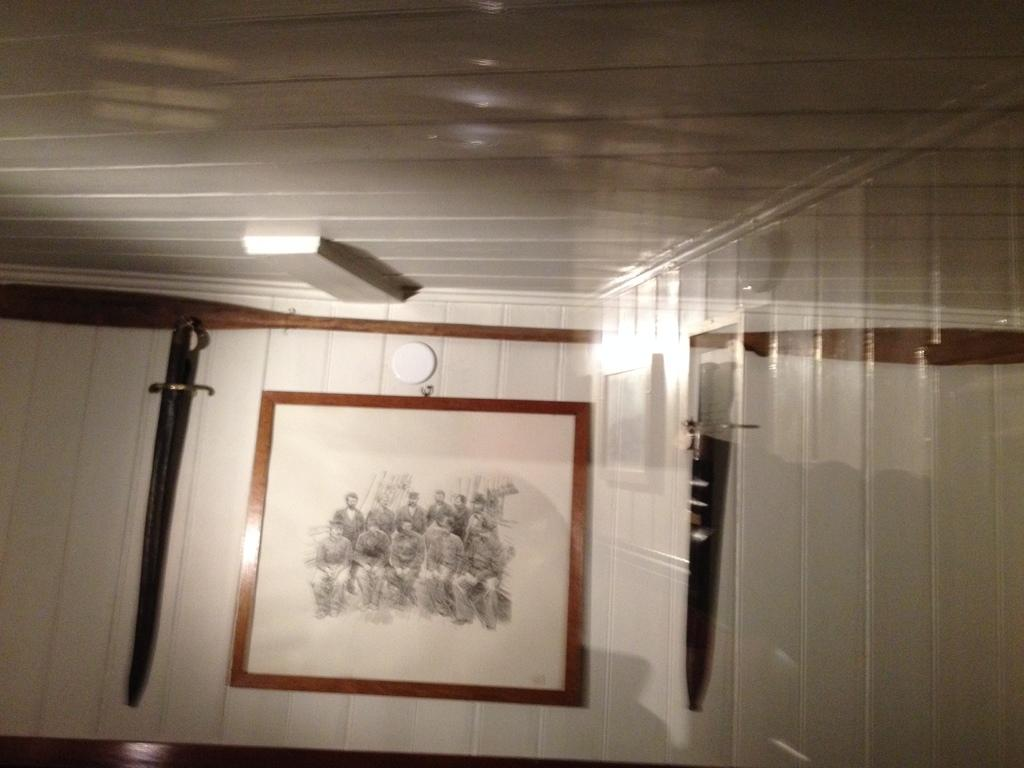What objects are present in the image that have frames? There are frames in the image, but the specific objects within the frames are not mentioned. What type of weapon can be seen in the image? There are swords in the image. What part of the room is visible from the image? The ceiling and walls are visible in the image. How much blood is visible on the swords in the image? There is no blood visible on the swords in the image. What type of home is depicted in the image? The provided facts do not mention any specific type of home or dwelling in the image. 